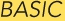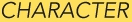What words are shown in these images in order, separated by a semicolon? BASIC; CHARACTER 